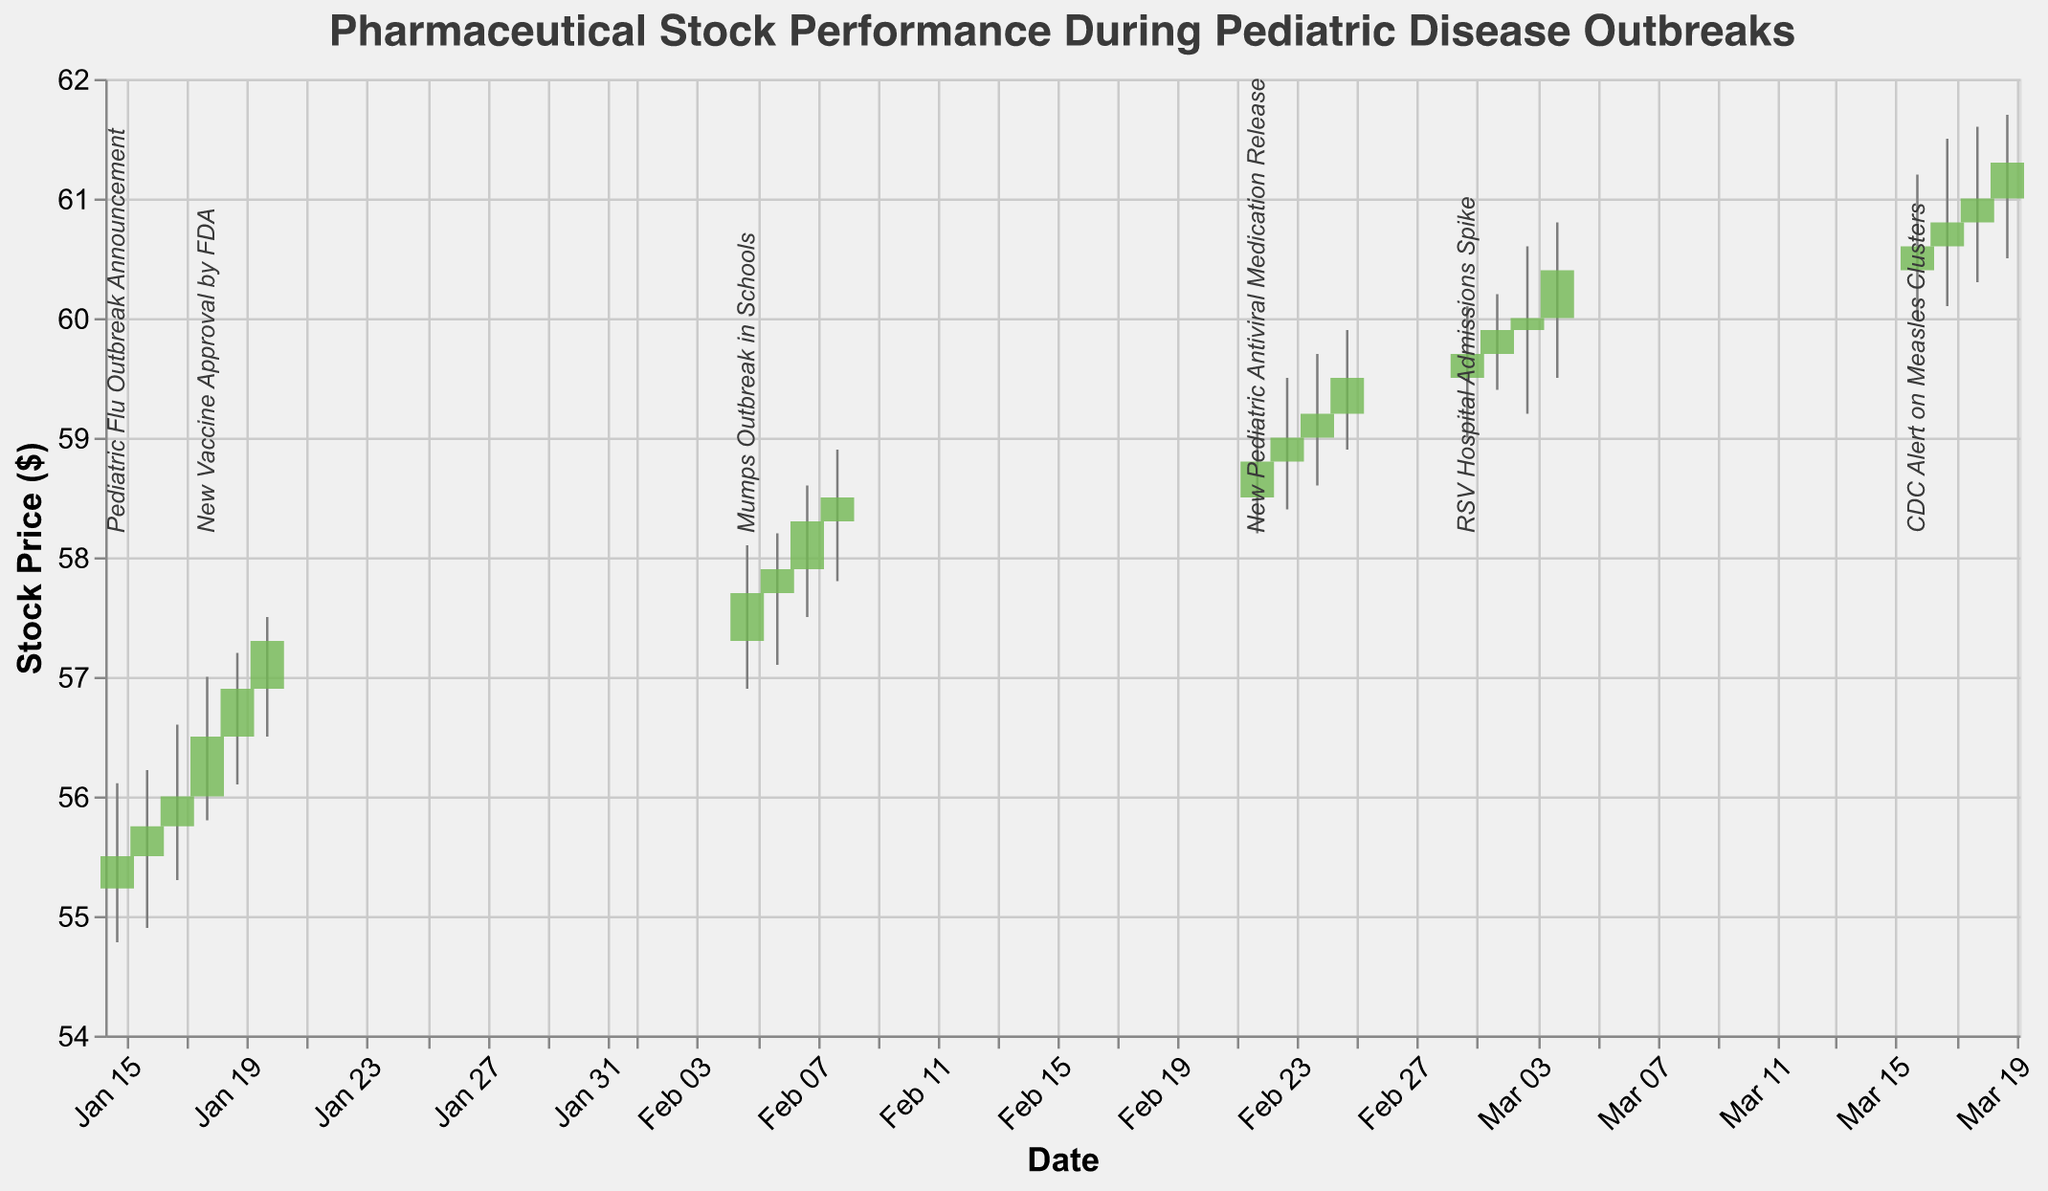How does the stock price change on the day of the "Pediatric Flu Outbreak Announcement"? Referring to the figure, the stock price opens at $55.23 and closes at $55.50. The announcement does not appear to dramatically impact the stock price as the closing price is slightly higher than the opening price.
Answer: Opens at $55.23 and closes at $55.50 What event caused the highest stock price during the analyzed period? Referring to the figure, the highest stock price is $61.70 on March 19, but there is no specific event on this date. The last notable event is the "CDC Alert on Measles Clusters" on March 16, which could have an impact around this date.
Answer: "CDC Alert on Measles Clusters" Compare the stock's lowest and highest prices during the examined period. What are these values? The lowest price occurs on January 15 at $54.78 and the highest price occurs on March 19 at $61.70. These two events show the range within which the stock has fluctuated during the analyzed period.
Answer: Lowest: $54.78, Highest: $61.70 What trend is observed in the stock price after the announcement of the "New Pediatric Antiviral Medication Release"? Referring to the figure, after the announcement on February 22, the closing prices show a consistent upward trend. The price closes at $58.80 on the announcement date and reaches $59.50 by February 25.
Answer: Upward trend How frequently do the stock prices close higher than they open after notable events during the given period? First, identify notable events. They are on January 15, January 18, February 5, February 22, March 1, and March 16. Check each to see if the closing price is higher than the opening price. January 15 (Yes), January 18 (Yes), February 5 (Yes), February 22 (Yes), March 1 (Yes), March 16 (Yes). Thus, the closing prices tend to close higher after each notable event within the given period.
Answer: All events show higher closing prices 